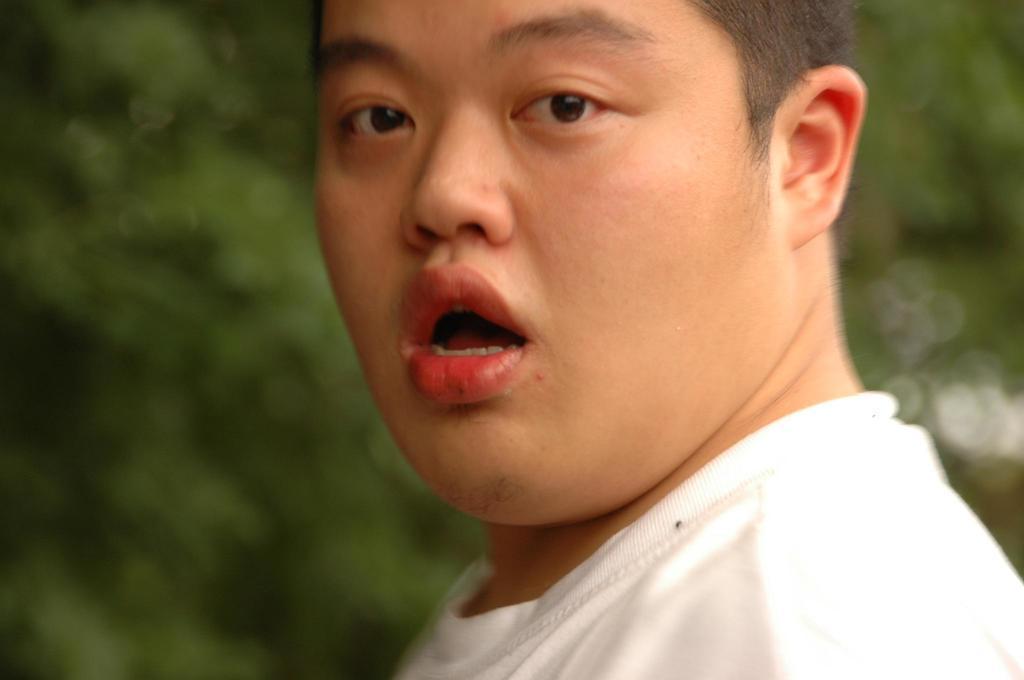Please provide a concise description of this image. In this picture we can see there is a man in the white t shirt and behind the man there is a blurred background. 